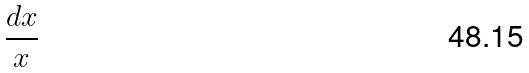<formula> <loc_0><loc_0><loc_500><loc_500>\frac { d x } { x }</formula> 